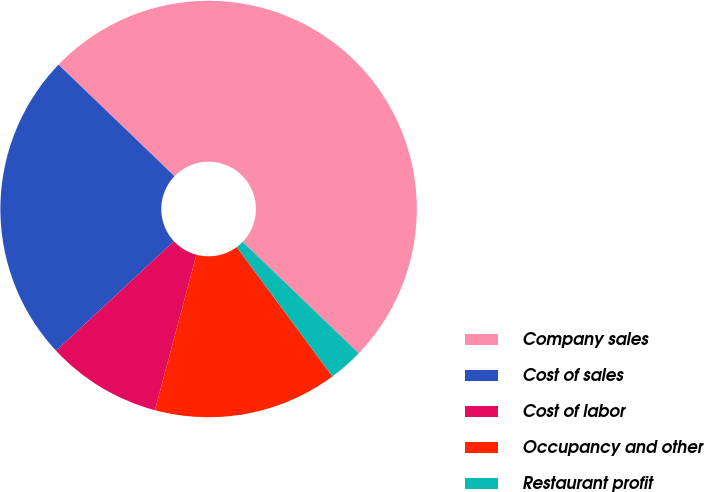Convert chart to OTSL. <chart><loc_0><loc_0><loc_500><loc_500><pie_chart><fcel>Company sales<fcel>Cost of sales<fcel>Cost of labor<fcel>Occupancy and other<fcel>Restaurant profit<nl><fcel>50.0%<fcel>24.11%<fcel>8.93%<fcel>14.29%<fcel>2.68%<nl></chart> 